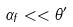Convert formula to latex. <formula><loc_0><loc_0><loc_500><loc_500>\alpha _ { f } < < \theta ^ { \prime }</formula> 